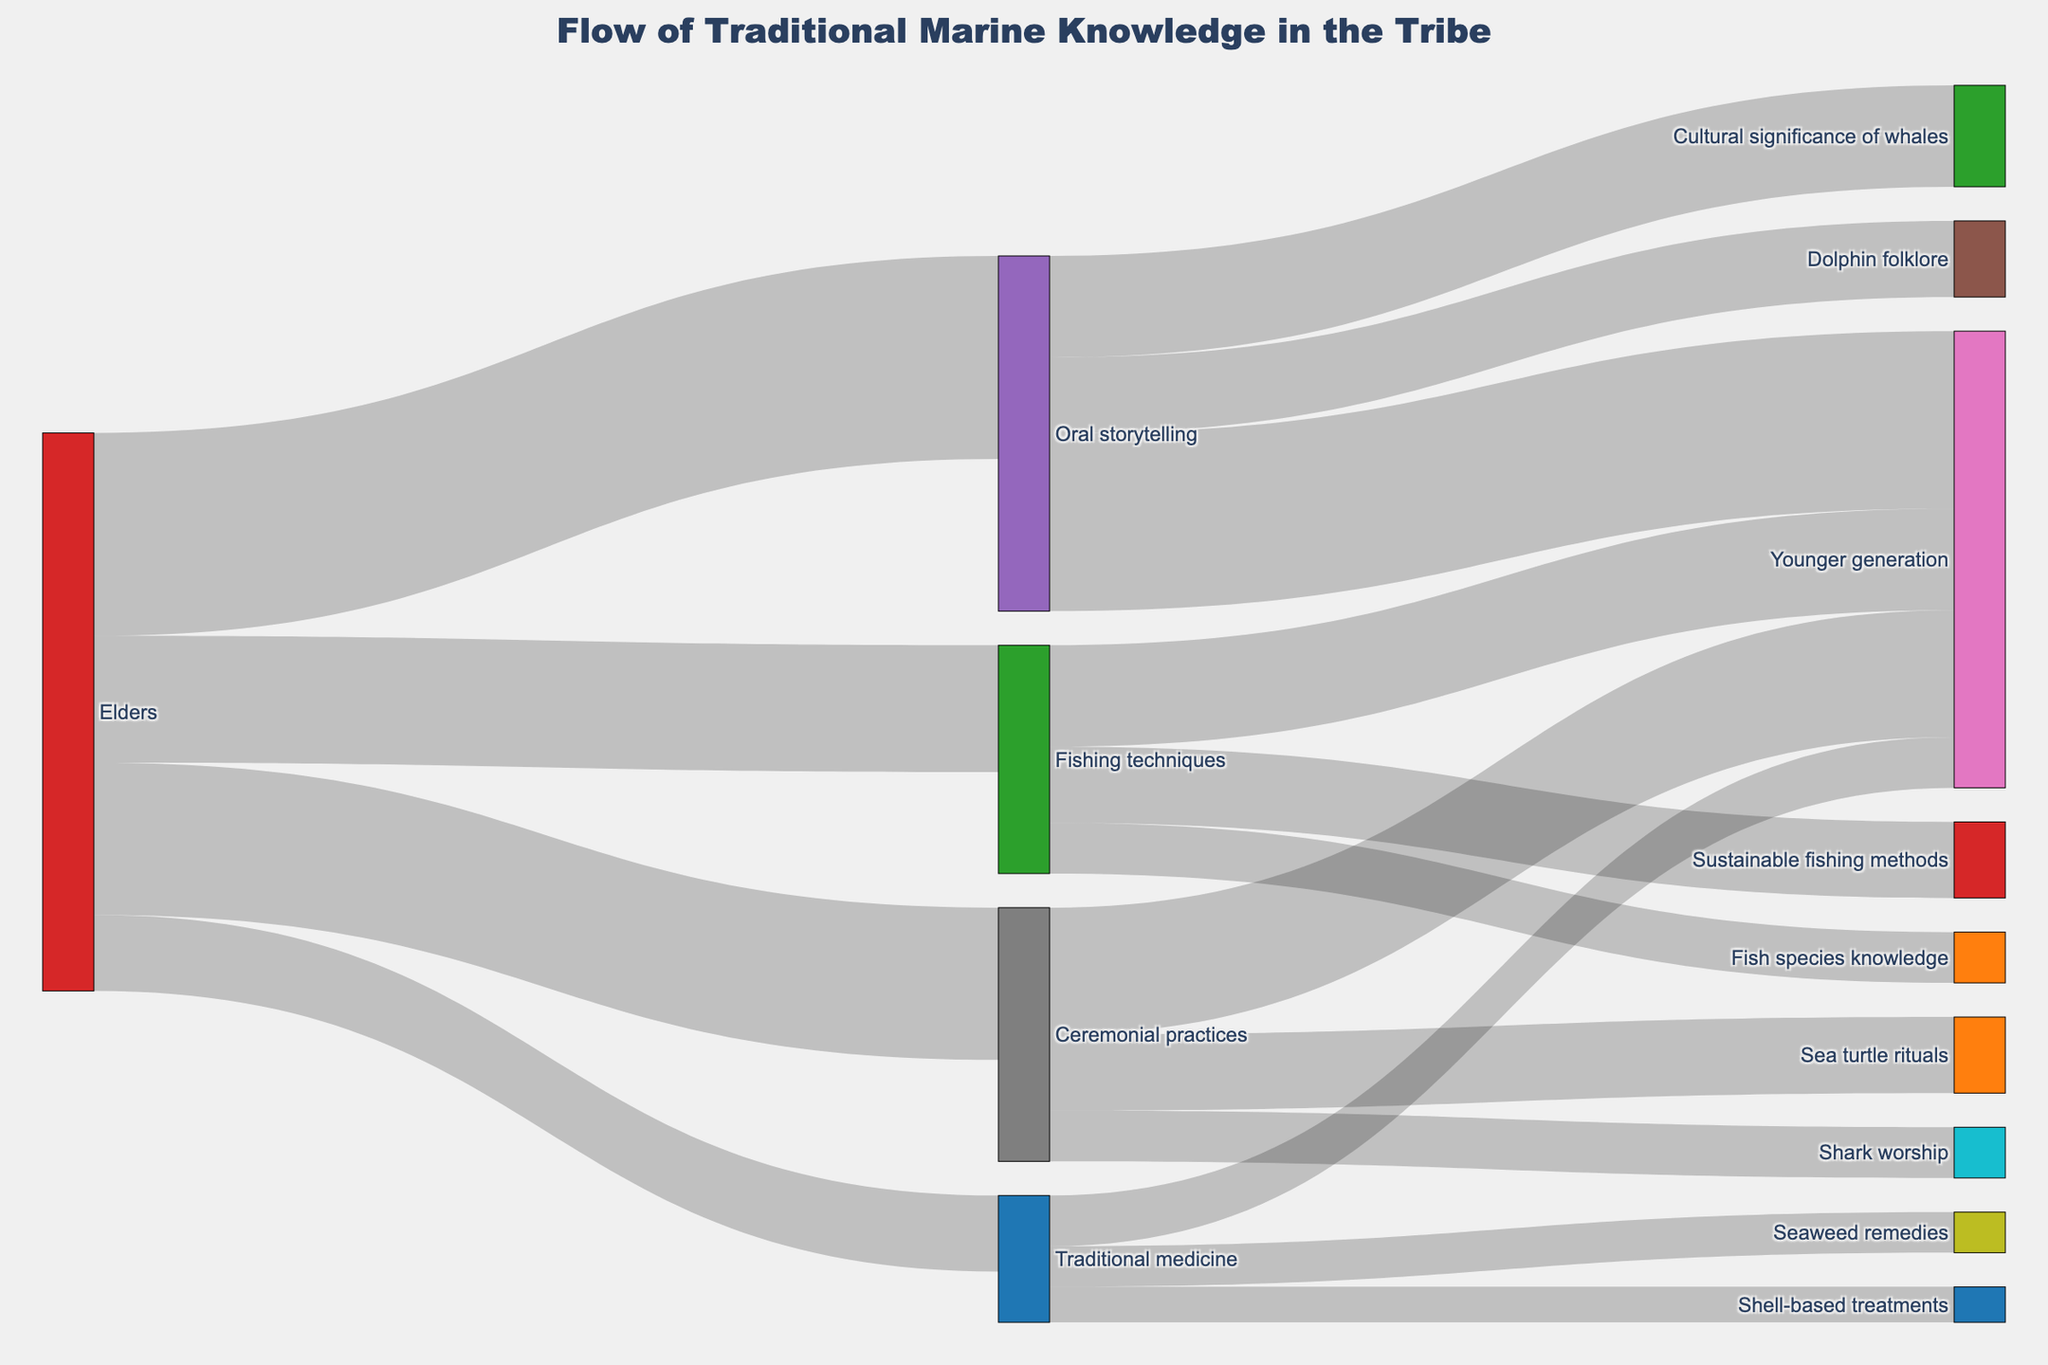What is the title of the Sankey Diagram? The title of the Sankey Diagram is prominently displayed at the top of the diagram. Titles are often centered and use a larger font size than other text.
Answer: Flow of Traditional Marine Knowledge in the Tribe Which source has the highest value flowing into the 'Younger generation'? By observing the links flowing into the 'Younger generation', we can see that 'Oral storytelling' has the highest value, as it is thicker than the others (35).
Answer: Oral storytelling What is the total value of traditional knowledge passed from elders to the younger generation through ceremonial practices? To find the total value, sum the portions related to ceremonial practices: 'Ceremonial practices' to 'Younger generation' (25), 'Shark worship' (10), and 'Sea turtle rituals' (15).
Answer: 50 How does the value of traditional medicine flowing to the younger generation compare to fishing techniques? Comparing the values of links flowing to 'Younger generation' through 'Traditional medicine' (10) and 'Fishing techniques' (20) shows that fishing techniques have a higher value.
Answer: Fishing techniques have a higher value Which area of marine knowledge passed through oral storytelling is the most significant? The widths of the links from 'Oral storytelling' point to 'Cultural significance of whales' (20) and 'Dolphin folklore' (15). The wider the link, the higher the value, indicating 'Cultural significance of whales' is the most significant.
Answer: Cultural significance of whales What is the total value for all knowledge flows originating from elders? Sum the values originating from elders: 'Oral storytelling' (40), 'Ceremonial practices' (30), 'Fishing techniques' (25), and 'Traditional medicine' (15). The total sum is 40 + 30 + 25 + 15.
Answer: 110 How much traditional knowledge about marine life is delivered through fishing techniques? Adding the values linked to fishing techniques: 'Sustainable fishing methods' (15) and 'Fish species knowledge' (10) gives the total.
Answer: 25 Compare the value of the 'Seaweed remedies' to 'Shell-based treatments' in the traditional medicine category. Values for 'Seaweed remedies' (8) and 'Shell-based treatments' (7) can be compared directly based on the diagram.
Answer: Seaweed remedies have a higher value From the Sankey Diagram, how is knowledge about sustainable fishing methods passed down? The path shows lineage starting from 'Elders', flowing into 'Fishing techniques', and directly into 'Sustainable fishing methods'. This indicates the direct transmission of knowledge.
Answer: From Elders to Fishing techniques to Sustainable fishing methods 